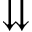Convert formula to latex. <formula><loc_0><loc_0><loc_500><loc_500>\downdownarrows</formula> 